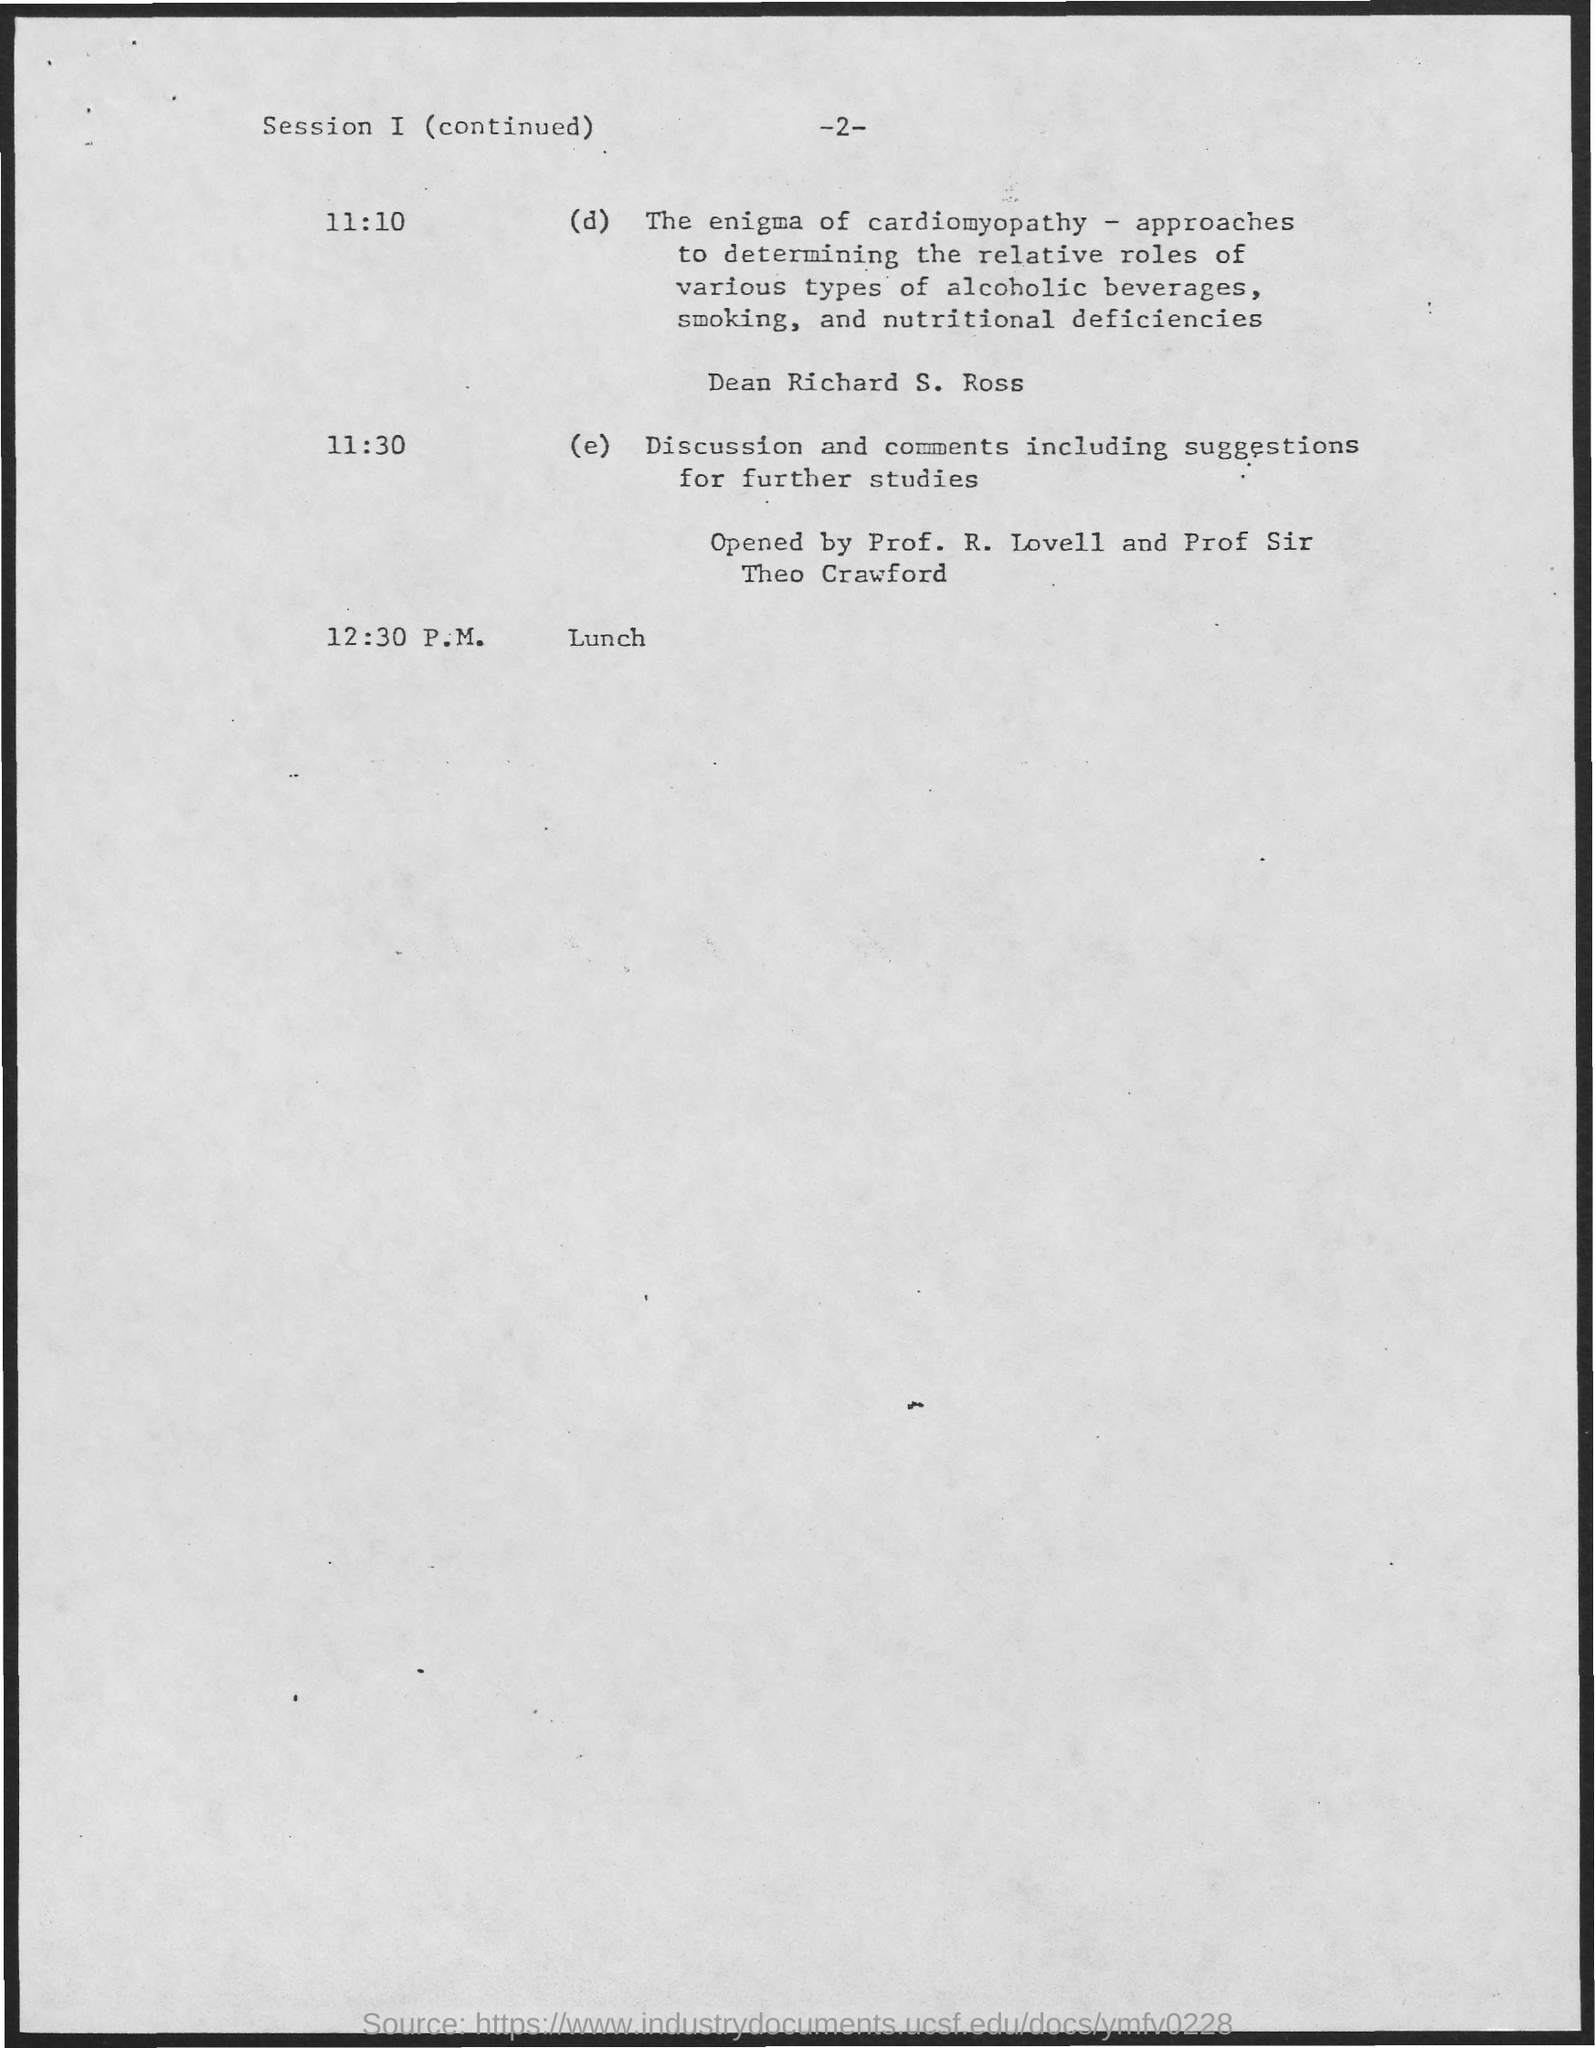Outline some significant characteristics in this image. The lunch will occur at 12:30 P.M. The discussion and comments, including suggestions for further studies, will take place at 11:30. 